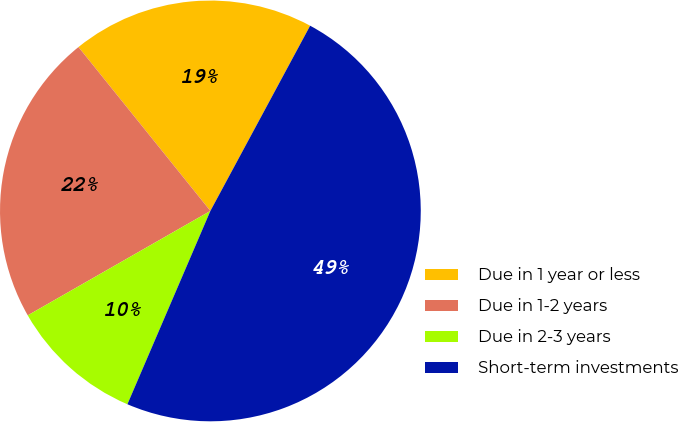Convert chart to OTSL. <chart><loc_0><loc_0><loc_500><loc_500><pie_chart><fcel>Due in 1 year or less<fcel>Due in 1-2 years<fcel>Due in 2-3 years<fcel>Short-term investments<nl><fcel>18.65%<fcel>22.48%<fcel>10.28%<fcel>48.59%<nl></chart> 